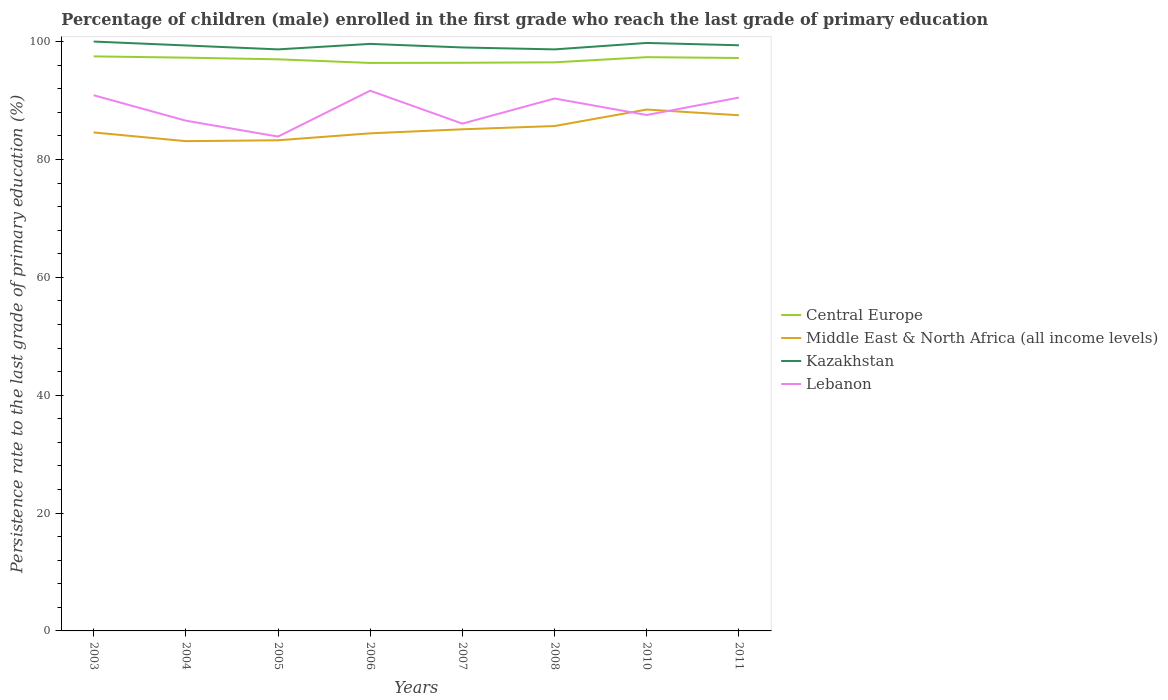Does the line corresponding to Lebanon intersect with the line corresponding to Kazakhstan?
Keep it short and to the point. No. Across all years, what is the maximum persistence rate of children in Middle East & North Africa (all income levels)?
Your response must be concise. 83.1. In which year was the persistence rate of children in Middle East & North Africa (all income levels) maximum?
Keep it short and to the point. 2004. What is the total persistence rate of children in Kazakhstan in the graph?
Your answer should be very brief. 0.66. What is the difference between the highest and the second highest persistence rate of children in Kazakhstan?
Provide a succinct answer. 1.33. What is the difference between the highest and the lowest persistence rate of children in Central Europe?
Your response must be concise. 5. How many lines are there?
Offer a terse response. 4. What is the difference between two consecutive major ticks on the Y-axis?
Keep it short and to the point. 20. Where does the legend appear in the graph?
Your answer should be very brief. Center right. How many legend labels are there?
Make the answer very short. 4. What is the title of the graph?
Provide a short and direct response. Percentage of children (male) enrolled in the first grade who reach the last grade of primary education. Does "United Arab Emirates" appear as one of the legend labels in the graph?
Offer a terse response. No. What is the label or title of the Y-axis?
Keep it short and to the point. Persistence rate to the last grade of primary education (%). What is the Persistence rate to the last grade of primary education (%) in Central Europe in 2003?
Your response must be concise. 97.48. What is the Persistence rate to the last grade of primary education (%) in Middle East & North Africa (all income levels) in 2003?
Your response must be concise. 84.58. What is the Persistence rate to the last grade of primary education (%) of Lebanon in 2003?
Offer a terse response. 90.89. What is the Persistence rate to the last grade of primary education (%) in Central Europe in 2004?
Give a very brief answer. 97.27. What is the Persistence rate to the last grade of primary education (%) of Middle East & North Africa (all income levels) in 2004?
Offer a terse response. 83.1. What is the Persistence rate to the last grade of primary education (%) in Kazakhstan in 2004?
Provide a short and direct response. 99.34. What is the Persistence rate to the last grade of primary education (%) of Lebanon in 2004?
Provide a short and direct response. 86.58. What is the Persistence rate to the last grade of primary education (%) in Central Europe in 2005?
Provide a succinct answer. 96.99. What is the Persistence rate to the last grade of primary education (%) in Middle East & North Africa (all income levels) in 2005?
Provide a succinct answer. 83.25. What is the Persistence rate to the last grade of primary education (%) of Kazakhstan in 2005?
Offer a terse response. 98.67. What is the Persistence rate to the last grade of primary education (%) of Lebanon in 2005?
Give a very brief answer. 83.88. What is the Persistence rate to the last grade of primary education (%) of Central Europe in 2006?
Ensure brevity in your answer.  96.37. What is the Persistence rate to the last grade of primary education (%) in Middle East & North Africa (all income levels) in 2006?
Make the answer very short. 84.43. What is the Persistence rate to the last grade of primary education (%) of Kazakhstan in 2006?
Your answer should be compact. 99.6. What is the Persistence rate to the last grade of primary education (%) of Lebanon in 2006?
Your response must be concise. 91.66. What is the Persistence rate to the last grade of primary education (%) of Central Europe in 2007?
Give a very brief answer. 96.4. What is the Persistence rate to the last grade of primary education (%) in Middle East & North Africa (all income levels) in 2007?
Your answer should be very brief. 85.11. What is the Persistence rate to the last grade of primary education (%) in Kazakhstan in 2007?
Make the answer very short. 99. What is the Persistence rate to the last grade of primary education (%) in Lebanon in 2007?
Offer a very short reply. 86.07. What is the Persistence rate to the last grade of primary education (%) of Central Europe in 2008?
Your response must be concise. 96.48. What is the Persistence rate to the last grade of primary education (%) in Middle East & North Africa (all income levels) in 2008?
Your answer should be very brief. 85.67. What is the Persistence rate to the last grade of primary education (%) of Kazakhstan in 2008?
Keep it short and to the point. 98.67. What is the Persistence rate to the last grade of primary education (%) in Lebanon in 2008?
Provide a short and direct response. 90.33. What is the Persistence rate to the last grade of primary education (%) in Central Europe in 2010?
Make the answer very short. 97.35. What is the Persistence rate to the last grade of primary education (%) of Middle East & North Africa (all income levels) in 2010?
Provide a succinct answer. 88.46. What is the Persistence rate to the last grade of primary education (%) in Kazakhstan in 2010?
Your answer should be very brief. 99.77. What is the Persistence rate to the last grade of primary education (%) of Lebanon in 2010?
Provide a short and direct response. 87.54. What is the Persistence rate to the last grade of primary education (%) of Central Europe in 2011?
Give a very brief answer. 97.21. What is the Persistence rate to the last grade of primary education (%) in Middle East & North Africa (all income levels) in 2011?
Your answer should be very brief. 87.49. What is the Persistence rate to the last grade of primary education (%) in Kazakhstan in 2011?
Your answer should be very brief. 99.37. What is the Persistence rate to the last grade of primary education (%) of Lebanon in 2011?
Provide a short and direct response. 90.49. Across all years, what is the maximum Persistence rate to the last grade of primary education (%) of Central Europe?
Offer a very short reply. 97.48. Across all years, what is the maximum Persistence rate to the last grade of primary education (%) in Middle East & North Africa (all income levels)?
Offer a very short reply. 88.46. Across all years, what is the maximum Persistence rate to the last grade of primary education (%) of Lebanon?
Your response must be concise. 91.66. Across all years, what is the minimum Persistence rate to the last grade of primary education (%) of Central Europe?
Give a very brief answer. 96.37. Across all years, what is the minimum Persistence rate to the last grade of primary education (%) in Middle East & North Africa (all income levels)?
Your answer should be compact. 83.1. Across all years, what is the minimum Persistence rate to the last grade of primary education (%) in Kazakhstan?
Ensure brevity in your answer.  98.67. Across all years, what is the minimum Persistence rate to the last grade of primary education (%) of Lebanon?
Offer a terse response. 83.88. What is the total Persistence rate to the last grade of primary education (%) of Central Europe in the graph?
Ensure brevity in your answer.  775.55. What is the total Persistence rate to the last grade of primary education (%) of Middle East & North Africa (all income levels) in the graph?
Provide a short and direct response. 682.09. What is the total Persistence rate to the last grade of primary education (%) of Kazakhstan in the graph?
Provide a short and direct response. 794.42. What is the total Persistence rate to the last grade of primary education (%) in Lebanon in the graph?
Provide a short and direct response. 707.45. What is the difference between the Persistence rate to the last grade of primary education (%) of Central Europe in 2003 and that in 2004?
Give a very brief answer. 0.22. What is the difference between the Persistence rate to the last grade of primary education (%) of Middle East & North Africa (all income levels) in 2003 and that in 2004?
Your answer should be very brief. 1.48. What is the difference between the Persistence rate to the last grade of primary education (%) in Kazakhstan in 2003 and that in 2004?
Offer a very short reply. 0.66. What is the difference between the Persistence rate to the last grade of primary education (%) in Lebanon in 2003 and that in 2004?
Give a very brief answer. 4.31. What is the difference between the Persistence rate to the last grade of primary education (%) of Central Europe in 2003 and that in 2005?
Keep it short and to the point. 0.5. What is the difference between the Persistence rate to the last grade of primary education (%) in Middle East & North Africa (all income levels) in 2003 and that in 2005?
Make the answer very short. 1.33. What is the difference between the Persistence rate to the last grade of primary education (%) in Kazakhstan in 2003 and that in 2005?
Provide a short and direct response. 1.33. What is the difference between the Persistence rate to the last grade of primary education (%) in Lebanon in 2003 and that in 2005?
Keep it short and to the point. 7.01. What is the difference between the Persistence rate to the last grade of primary education (%) in Central Europe in 2003 and that in 2006?
Make the answer very short. 1.11. What is the difference between the Persistence rate to the last grade of primary education (%) in Middle East & North Africa (all income levels) in 2003 and that in 2006?
Keep it short and to the point. 0.15. What is the difference between the Persistence rate to the last grade of primary education (%) in Kazakhstan in 2003 and that in 2006?
Your response must be concise. 0.4. What is the difference between the Persistence rate to the last grade of primary education (%) in Lebanon in 2003 and that in 2006?
Ensure brevity in your answer.  -0.77. What is the difference between the Persistence rate to the last grade of primary education (%) of Central Europe in 2003 and that in 2007?
Your answer should be compact. 1.08. What is the difference between the Persistence rate to the last grade of primary education (%) in Middle East & North Africa (all income levels) in 2003 and that in 2007?
Keep it short and to the point. -0.53. What is the difference between the Persistence rate to the last grade of primary education (%) of Lebanon in 2003 and that in 2007?
Make the answer very short. 4.82. What is the difference between the Persistence rate to the last grade of primary education (%) of Central Europe in 2003 and that in 2008?
Your answer should be very brief. 1.01. What is the difference between the Persistence rate to the last grade of primary education (%) of Middle East & North Africa (all income levels) in 2003 and that in 2008?
Make the answer very short. -1.09. What is the difference between the Persistence rate to the last grade of primary education (%) in Kazakhstan in 2003 and that in 2008?
Offer a very short reply. 1.33. What is the difference between the Persistence rate to the last grade of primary education (%) of Lebanon in 2003 and that in 2008?
Provide a short and direct response. 0.56. What is the difference between the Persistence rate to the last grade of primary education (%) in Central Europe in 2003 and that in 2010?
Offer a very short reply. 0.13. What is the difference between the Persistence rate to the last grade of primary education (%) in Middle East & North Africa (all income levels) in 2003 and that in 2010?
Your answer should be compact. -3.88. What is the difference between the Persistence rate to the last grade of primary education (%) of Kazakhstan in 2003 and that in 2010?
Your response must be concise. 0.23. What is the difference between the Persistence rate to the last grade of primary education (%) in Lebanon in 2003 and that in 2010?
Give a very brief answer. 3.35. What is the difference between the Persistence rate to the last grade of primary education (%) of Central Europe in 2003 and that in 2011?
Your answer should be compact. 0.27. What is the difference between the Persistence rate to the last grade of primary education (%) of Middle East & North Africa (all income levels) in 2003 and that in 2011?
Provide a succinct answer. -2.91. What is the difference between the Persistence rate to the last grade of primary education (%) in Kazakhstan in 2003 and that in 2011?
Your answer should be compact. 0.63. What is the difference between the Persistence rate to the last grade of primary education (%) in Lebanon in 2003 and that in 2011?
Your response must be concise. 0.4. What is the difference between the Persistence rate to the last grade of primary education (%) of Central Europe in 2004 and that in 2005?
Provide a succinct answer. 0.28. What is the difference between the Persistence rate to the last grade of primary education (%) in Middle East & North Africa (all income levels) in 2004 and that in 2005?
Your answer should be compact. -0.15. What is the difference between the Persistence rate to the last grade of primary education (%) of Kazakhstan in 2004 and that in 2005?
Keep it short and to the point. 0.66. What is the difference between the Persistence rate to the last grade of primary education (%) of Lebanon in 2004 and that in 2005?
Offer a terse response. 2.7. What is the difference between the Persistence rate to the last grade of primary education (%) in Central Europe in 2004 and that in 2006?
Your answer should be very brief. 0.9. What is the difference between the Persistence rate to the last grade of primary education (%) of Middle East & North Africa (all income levels) in 2004 and that in 2006?
Your answer should be very brief. -1.33. What is the difference between the Persistence rate to the last grade of primary education (%) of Kazakhstan in 2004 and that in 2006?
Your answer should be compact. -0.27. What is the difference between the Persistence rate to the last grade of primary education (%) of Lebanon in 2004 and that in 2006?
Give a very brief answer. -5.09. What is the difference between the Persistence rate to the last grade of primary education (%) in Central Europe in 2004 and that in 2007?
Your answer should be compact. 0.87. What is the difference between the Persistence rate to the last grade of primary education (%) in Middle East & North Africa (all income levels) in 2004 and that in 2007?
Keep it short and to the point. -2.01. What is the difference between the Persistence rate to the last grade of primary education (%) of Kazakhstan in 2004 and that in 2007?
Your answer should be compact. 0.34. What is the difference between the Persistence rate to the last grade of primary education (%) in Lebanon in 2004 and that in 2007?
Your answer should be compact. 0.5. What is the difference between the Persistence rate to the last grade of primary education (%) in Central Europe in 2004 and that in 2008?
Make the answer very short. 0.79. What is the difference between the Persistence rate to the last grade of primary education (%) in Middle East & North Africa (all income levels) in 2004 and that in 2008?
Ensure brevity in your answer.  -2.57. What is the difference between the Persistence rate to the last grade of primary education (%) in Kazakhstan in 2004 and that in 2008?
Make the answer very short. 0.67. What is the difference between the Persistence rate to the last grade of primary education (%) in Lebanon in 2004 and that in 2008?
Ensure brevity in your answer.  -3.76. What is the difference between the Persistence rate to the last grade of primary education (%) in Central Europe in 2004 and that in 2010?
Offer a terse response. -0.09. What is the difference between the Persistence rate to the last grade of primary education (%) of Middle East & North Africa (all income levels) in 2004 and that in 2010?
Ensure brevity in your answer.  -5.36. What is the difference between the Persistence rate to the last grade of primary education (%) of Kazakhstan in 2004 and that in 2010?
Your answer should be compact. -0.43. What is the difference between the Persistence rate to the last grade of primary education (%) of Lebanon in 2004 and that in 2010?
Offer a terse response. -0.96. What is the difference between the Persistence rate to the last grade of primary education (%) in Central Europe in 2004 and that in 2011?
Your answer should be compact. 0.06. What is the difference between the Persistence rate to the last grade of primary education (%) in Middle East & North Africa (all income levels) in 2004 and that in 2011?
Provide a succinct answer. -4.39. What is the difference between the Persistence rate to the last grade of primary education (%) of Kazakhstan in 2004 and that in 2011?
Offer a very short reply. -0.03. What is the difference between the Persistence rate to the last grade of primary education (%) in Lebanon in 2004 and that in 2011?
Offer a terse response. -3.92. What is the difference between the Persistence rate to the last grade of primary education (%) in Central Europe in 2005 and that in 2006?
Your response must be concise. 0.61. What is the difference between the Persistence rate to the last grade of primary education (%) in Middle East & North Africa (all income levels) in 2005 and that in 2006?
Provide a short and direct response. -1.18. What is the difference between the Persistence rate to the last grade of primary education (%) of Kazakhstan in 2005 and that in 2006?
Give a very brief answer. -0.93. What is the difference between the Persistence rate to the last grade of primary education (%) in Lebanon in 2005 and that in 2006?
Give a very brief answer. -7.78. What is the difference between the Persistence rate to the last grade of primary education (%) of Central Europe in 2005 and that in 2007?
Your answer should be very brief. 0.59. What is the difference between the Persistence rate to the last grade of primary education (%) in Middle East & North Africa (all income levels) in 2005 and that in 2007?
Provide a succinct answer. -1.86. What is the difference between the Persistence rate to the last grade of primary education (%) in Kazakhstan in 2005 and that in 2007?
Offer a very short reply. -0.33. What is the difference between the Persistence rate to the last grade of primary education (%) in Lebanon in 2005 and that in 2007?
Your answer should be very brief. -2.19. What is the difference between the Persistence rate to the last grade of primary education (%) of Central Europe in 2005 and that in 2008?
Ensure brevity in your answer.  0.51. What is the difference between the Persistence rate to the last grade of primary education (%) in Middle East & North Africa (all income levels) in 2005 and that in 2008?
Your response must be concise. -2.41. What is the difference between the Persistence rate to the last grade of primary education (%) in Kazakhstan in 2005 and that in 2008?
Provide a short and direct response. 0. What is the difference between the Persistence rate to the last grade of primary education (%) in Lebanon in 2005 and that in 2008?
Make the answer very short. -6.46. What is the difference between the Persistence rate to the last grade of primary education (%) of Central Europe in 2005 and that in 2010?
Offer a terse response. -0.37. What is the difference between the Persistence rate to the last grade of primary education (%) of Middle East & North Africa (all income levels) in 2005 and that in 2010?
Offer a very short reply. -5.21. What is the difference between the Persistence rate to the last grade of primary education (%) in Kazakhstan in 2005 and that in 2010?
Keep it short and to the point. -1.09. What is the difference between the Persistence rate to the last grade of primary education (%) of Lebanon in 2005 and that in 2010?
Offer a terse response. -3.66. What is the difference between the Persistence rate to the last grade of primary education (%) in Central Europe in 2005 and that in 2011?
Provide a short and direct response. -0.22. What is the difference between the Persistence rate to the last grade of primary education (%) of Middle East & North Africa (all income levels) in 2005 and that in 2011?
Make the answer very short. -4.24. What is the difference between the Persistence rate to the last grade of primary education (%) of Kazakhstan in 2005 and that in 2011?
Provide a succinct answer. -0.7. What is the difference between the Persistence rate to the last grade of primary education (%) in Lebanon in 2005 and that in 2011?
Give a very brief answer. -6.61. What is the difference between the Persistence rate to the last grade of primary education (%) in Central Europe in 2006 and that in 2007?
Ensure brevity in your answer.  -0.03. What is the difference between the Persistence rate to the last grade of primary education (%) in Middle East & North Africa (all income levels) in 2006 and that in 2007?
Keep it short and to the point. -0.68. What is the difference between the Persistence rate to the last grade of primary education (%) of Kazakhstan in 2006 and that in 2007?
Offer a terse response. 0.6. What is the difference between the Persistence rate to the last grade of primary education (%) of Lebanon in 2006 and that in 2007?
Offer a very short reply. 5.59. What is the difference between the Persistence rate to the last grade of primary education (%) of Central Europe in 2006 and that in 2008?
Ensure brevity in your answer.  -0.1. What is the difference between the Persistence rate to the last grade of primary education (%) in Middle East & North Africa (all income levels) in 2006 and that in 2008?
Make the answer very short. -1.24. What is the difference between the Persistence rate to the last grade of primary education (%) of Kazakhstan in 2006 and that in 2008?
Your answer should be compact. 0.93. What is the difference between the Persistence rate to the last grade of primary education (%) of Lebanon in 2006 and that in 2008?
Offer a terse response. 1.33. What is the difference between the Persistence rate to the last grade of primary education (%) of Central Europe in 2006 and that in 2010?
Give a very brief answer. -0.98. What is the difference between the Persistence rate to the last grade of primary education (%) in Middle East & North Africa (all income levels) in 2006 and that in 2010?
Give a very brief answer. -4.04. What is the difference between the Persistence rate to the last grade of primary education (%) in Kazakhstan in 2006 and that in 2010?
Your answer should be compact. -0.16. What is the difference between the Persistence rate to the last grade of primary education (%) of Lebanon in 2006 and that in 2010?
Offer a very short reply. 4.13. What is the difference between the Persistence rate to the last grade of primary education (%) of Central Europe in 2006 and that in 2011?
Provide a short and direct response. -0.84. What is the difference between the Persistence rate to the last grade of primary education (%) in Middle East & North Africa (all income levels) in 2006 and that in 2011?
Keep it short and to the point. -3.06. What is the difference between the Persistence rate to the last grade of primary education (%) of Kazakhstan in 2006 and that in 2011?
Your response must be concise. 0.23. What is the difference between the Persistence rate to the last grade of primary education (%) of Lebanon in 2006 and that in 2011?
Give a very brief answer. 1.17. What is the difference between the Persistence rate to the last grade of primary education (%) of Central Europe in 2007 and that in 2008?
Your answer should be very brief. -0.08. What is the difference between the Persistence rate to the last grade of primary education (%) in Middle East & North Africa (all income levels) in 2007 and that in 2008?
Provide a short and direct response. -0.55. What is the difference between the Persistence rate to the last grade of primary education (%) in Kazakhstan in 2007 and that in 2008?
Your answer should be very brief. 0.33. What is the difference between the Persistence rate to the last grade of primary education (%) in Lebanon in 2007 and that in 2008?
Offer a very short reply. -4.26. What is the difference between the Persistence rate to the last grade of primary education (%) of Central Europe in 2007 and that in 2010?
Your response must be concise. -0.95. What is the difference between the Persistence rate to the last grade of primary education (%) of Middle East & North Africa (all income levels) in 2007 and that in 2010?
Offer a very short reply. -3.35. What is the difference between the Persistence rate to the last grade of primary education (%) in Kazakhstan in 2007 and that in 2010?
Make the answer very short. -0.77. What is the difference between the Persistence rate to the last grade of primary education (%) in Lebanon in 2007 and that in 2010?
Offer a terse response. -1.46. What is the difference between the Persistence rate to the last grade of primary education (%) in Central Europe in 2007 and that in 2011?
Give a very brief answer. -0.81. What is the difference between the Persistence rate to the last grade of primary education (%) of Middle East & North Africa (all income levels) in 2007 and that in 2011?
Give a very brief answer. -2.38. What is the difference between the Persistence rate to the last grade of primary education (%) in Kazakhstan in 2007 and that in 2011?
Provide a short and direct response. -0.37. What is the difference between the Persistence rate to the last grade of primary education (%) in Lebanon in 2007 and that in 2011?
Keep it short and to the point. -4.42. What is the difference between the Persistence rate to the last grade of primary education (%) in Central Europe in 2008 and that in 2010?
Your answer should be very brief. -0.88. What is the difference between the Persistence rate to the last grade of primary education (%) in Middle East & North Africa (all income levels) in 2008 and that in 2010?
Your answer should be compact. -2.8. What is the difference between the Persistence rate to the last grade of primary education (%) in Kazakhstan in 2008 and that in 2010?
Your response must be concise. -1.1. What is the difference between the Persistence rate to the last grade of primary education (%) in Lebanon in 2008 and that in 2010?
Give a very brief answer. 2.8. What is the difference between the Persistence rate to the last grade of primary education (%) in Central Europe in 2008 and that in 2011?
Offer a very short reply. -0.74. What is the difference between the Persistence rate to the last grade of primary education (%) in Middle East & North Africa (all income levels) in 2008 and that in 2011?
Offer a terse response. -1.83. What is the difference between the Persistence rate to the last grade of primary education (%) of Kazakhstan in 2008 and that in 2011?
Your answer should be compact. -0.7. What is the difference between the Persistence rate to the last grade of primary education (%) in Lebanon in 2008 and that in 2011?
Keep it short and to the point. -0.16. What is the difference between the Persistence rate to the last grade of primary education (%) in Central Europe in 2010 and that in 2011?
Give a very brief answer. 0.14. What is the difference between the Persistence rate to the last grade of primary education (%) of Middle East & North Africa (all income levels) in 2010 and that in 2011?
Your response must be concise. 0.97. What is the difference between the Persistence rate to the last grade of primary education (%) of Kazakhstan in 2010 and that in 2011?
Give a very brief answer. 0.4. What is the difference between the Persistence rate to the last grade of primary education (%) of Lebanon in 2010 and that in 2011?
Provide a short and direct response. -2.96. What is the difference between the Persistence rate to the last grade of primary education (%) in Central Europe in 2003 and the Persistence rate to the last grade of primary education (%) in Middle East & North Africa (all income levels) in 2004?
Keep it short and to the point. 14.38. What is the difference between the Persistence rate to the last grade of primary education (%) in Central Europe in 2003 and the Persistence rate to the last grade of primary education (%) in Kazakhstan in 2004?
Provide a short and direct response. -1.85. What is the difference between the Persistence rate to the last grade of primary education (%) in Central Europe in 2003 and the Persistence rate to the last grade of primary education (%) in Lebanon in 2004?
Your answer should be compact. 10.91. What is the difference between the Persistence rate to the last grade of primary education (%) in Middle East & North Africa (all income levels) in 2003 and the Persistence rate to the last grade of primary education (%) in Kazakhstan in 2004?
Keep it short and to the point. -14.76. What is the difference between the Persistence rate to the last grade of primary education (%) of Middle East & North Africa (all income levels) in 2003 and the Persistence rate to the last grade of primary education (%) of Lebanon in 2004?
Make the answer very short. -2. What is the difference between the Persistence rate to the last grade of primary education (%) in Kazakhstan in 2003 and the Persistence rate to the last grade of primary education (%) in Lebanon in 2004?
Your response must be concise. 13.42. What is the difference between the Persistence rate to the last grade of primary education (%) of Central Europe in 2003 and the Persistence rate to the last grade of primary education (%) of Middle East & North Africa (all income levels) in 2005?
Offer a terse response. 14.23. What is the difference between the Persistence rate to the last grade of primary education (%) of Central Europe in 2003 and the Persistence rate to the last grade of primary education (%) of Kazakhstan in 2005?
Your answer should be compact. -1.19. What is the difference between the Persistence rate to the last grade of primary education (%) of Central Europe in 2003 and the Persistence rate to the last grade of primary education (%) of Lebanon in 2005?
Keep it short and to the point. 13.61. What is the difference between the Persistence rate to the last grade of primary education (%) of Middle East & North Africa (all income levels) in 2003 and the Persistence rate to the last grade of primary education (%) of Kazakhstan in 2005?
Your answer should be very brief. -14.09. What is the difference between the Persistence rate to the last grade of primary education (%) in Middle East & North Africa (all income levels) in 2003 and the Persistence rate to the last grade of primary education (%) in Lebanon in 2005?
Give a very brief answer. 0.7. What is the difference between the Persistence rate to the last grade of primary education (%) in Kazakhstan in 2003 and the Persistence rate to the last grade of primary education (%) in Lebanon in 2005?
Make the answer very short. 16.12. What is the difference between the Persistence rate to the last grade of primary education (%) of Central Europe in 2003 and the Persistence rate to the last grade of primary education (%) of Middle East & North Africa (all income levels) in 2006?
Make the answer very short. 13.06. What is the difference between the Persistence rate to the last grade of primary education (%) of Central Europe in 2003 and the Persistence rate to the last grade of primary education (%) of Kazakhstan in 2006?
Your answer should be compact. -2.12. What is the difference between the Persistence rate to the last grade of primary education (%) of Central Europe in 2003 and the Persistence rate to the last grade of primary education (%) of Lebanon in 2006?
Ensure brevity in your answer.  5.82. What is the difference between the Persistence rate to the last grade of primary education (%) in Middle East & North Africa (all income levels) in 2003 and the Persistence rate to the last grade of primary education (%) in Kazakhstan in 2006?
Offer a terse response. -15.02. What is the difference between the Persistence rate to the last grade of primary education (%) of Middle East & North Africa (all income levels) in 2003 and the Persistence rate to the last grade of primary education (%) of Lebanon in 2006?
Your answer should be compact. -7.08. What is the difference between the Persistence rate to the last grade of primary education (%) in Kazakhstan in 2003 and the Persistence rate to the last grade of primary education (%) in Lebanon in 2006?
Make the answer very short. 8.34. What is the difference between the Persistence rate to the last grade of primary education (%) of Central Europe in 2003 and the Persistence rate to the last grade of primary education (%) of Middle East & North Africa (all income levels) in 2007?
Keep it short and to the point. 12.37. What is the difference between the Persistence rate to the last grade of primary education (%) of Central Europe in 2003 and the Persistence rate to the last grade of primary education (%) of Kazakhstan in 2007?
Give a very brief answer. -1.51. What is the difference between the Persistence rate to the last grade of primary education (%) in Central Europe in 2003 and the Persistence rate to the last grade of primary education (%) in Lebanon in 2007?
Make the answer very short. 11.41. What is the difference between the Persistence rate to the last grade of primary education (%) in Middle East & North Africa (all income levels) in 2003 and the Persistence rate to the last grade of primary education (%) in Kazakhstan in 2007?
Your answer should be compact. -14.42. What is the difference between the Persistence rate to the last grade of primary education (%) of Middle East & North Africa (all income levels) in 2003 and the Persistence rate to the last grade of primary education (%) of Lebanon in 2007?
Make the answer very short. -1.49. What is the difference between the Persistence rate to the last grade of primary education (%) in Kazakhstan in 2003 and the Persistence rate to the last grade of primary education (%) in Lebanon in 2007?
Your answer should be compact. 13.93. What is the difference between the Persistence rate to the last grade of primary education (%) of Central Europe in 2003 and the Persistence rate to the last grade of primary education (%) of Middle East & North Africa (all income levels) in 2008?
Your answer should be compact. 11.82. What is the difference between the Persistence rate to the last grade of primary education (%) in Central Europe in 2003 and the Persistence rate to the last grade of primary education (%) in Kazakhstan in 2008?
Offer a terse response. -1.19. What is the difference between the Persistence rate to the last grade of primary education (%) in Central Europe in 2003 and the Persistence rate to the last grade of primary education (%) in Lebanon in 2008?
Your answer should be compact. 7.15. What is the difference between the Persistence rate to the last grade of primary education (%) in Middle East & North Africa (all income levels) in 2003 and the Persistence rate to the last grade of primary education (%) in Kazakhstan in 2008?
Keep it short and to the point. -14.09. What is the difference between the Persistence rate to the last grade of primary education (%) of Middle East & North Africa (all income levels) in 2003 and the Persistence rate to the last grade of primary education (%) of Lebanon in 2008?
Keep it short and to the point. -5.75. What is the difference between the Persistence rate to the last grade of primary education (%) in Kazakhstan in 2003 and the Persistence rate to the last grade of primary education (%) in Lebanon in 2008?
Offer a terse response. 9.67. What is the difference between the Persistence rate to the last grade of primary education (%) in Central Europe in 2003 and the Persistence rate to the last grade of primary education (%) in Middle East & North Africa (all income levels) in 2010?
Ensure brevity in your answer.  9.02. What is the difference between the Persistence rate to the last grade of primary education (%) of Central Europe in 2003 and the Persistence rate to the last grade of primary education (%) of Kazakhstan in 2010?
Provide a succinct answer. -2.28. What is the difference between the Persistence rate to the last grade of primary education (%) of Central Europe in 2003 and the Persistence rate to the last grade of primary education (%) of Lebanon in 2010?
Your response must be concise. 9.95. What is the difference between the Persistence rate to the last grade of primary education (%) of Middle East & North Africa (all income levels) in 2003 and the Persistence rate to the last grade of primary education (%) of Kazakhstan in 2010?
Keep it short and to the point. -15.19. What is the difference between the Persistence rate to the last grade of primary education (%) in Middle East & North Africa (all income levels) in 2003 and the Persistence rate to the last grade of primary education (%) in Lebanon in 2010?
Offer a very short reply. -2.96. What is the difference between the Persistence rate to the last grade of primary education (%) of Kazakhstan in 2003 and the Persistence rate to the last grade of primary education (%) of Lebanon in 2010?
Provide a succinct answer. 12.46. What is the difference between the Persistence rate to the last grade of primary education (%) of Central Europe in 2003 and the Persistence rate to the last grade of primary education (%) of Middle East & North Africa (all income levels) in 2011?
Offer a very short reply. 9.99. What is the difference between the Persistence rate to the last grade of primary education (%) of Central Europe in 2003 and the Persistence rate to the last grade of primary education (%) of Kazakhstan in 2011?
Make the answer very short. -1.89. What is the difference between the Persistence rate to the last grade of primary education (%) of Central Europe in 2003 and the Persistence rate to the last grade of primary education (%) of Lebanon in 2011?
Make the answer very short. 6.99. What is the difference between the Persistence rate to the last grade of primary education (%) of Middle East & North Africa (all income levels) in 2003 and the Persistence rate to the last grade of primary education (%) of Kazakhstan in 2011?
Ensure brevity in your answer.  -14.79. What is the difference between the Persistence rate to the last grade of primary education (%) of Middle East & North Africa (all income levels) in 2003 and the Persistence rate to the last grade of primary education (%) of Lebanon in 2011?
Make the answer very short. -5.91. What is the difference between the Persistence rate to the last grade of primary education (%) in Kazakhstan in 2003 and the Persistence rate to the last grade of primary education (%) in Lebanon in 2011?
Keep it short and to the point. 9.51. What is the difference between the Persistence rate to the last grade of primary education (%) in Central Europe in 2004 and the Persistence rate to the last grade of primary education (%) in Middle East & North Africa (all income levels) in 2005?
Your answer should be compact. 14.02. What is the difference between the Persistence rate to the last grade of primary education (%) of Central Europe in 2004 and the Persistence rate to the last grade of primary education (%) of Kazakhstan in 2005?
Ensure brevity in your answer.  -1.41. What is the difference between the Persistence rate to the last grade of primary education (%) of Central Europe in 2004 and the Persistence rate to the last grade of primary education (%) of Lebanon in 2005?
Ensure brevity in your answer.  13.39. What is the difference between the Persistence rate to the last grade of primary education (%) of Middle East & North Africa (all income levels) in 2004 and the Persistence rate to the last grade of primary education (%) of Kazakhstan in 2005?
Offer a terse response. -15.57. What is the difference between the Persistence rate to the last grade of primary education (%) in Middle East & North Africa (all income levels) in 2004 and the Persistence rate to the last grade of primary education (%) in Lebanon in 2005?
Make the answer very short. -0.78. What is the difference between the Persistence rate to the last grade of primary education (%) in Kazakhstan in 2004 and the Persistence rate to the last grade of primary education (%) in Lebanon in 2005?
Ensure brevity in your answer.  15.46. What is the difference between the Persistence rate to the last grade of primary education (%) of Central Europe in 2004 and the Persistence rate to the last grade of primary education (%) of Middle East & North Africa (all income levels) in 2006?
Your answer should be very brief. 12.84. What is the difference between the Persistence rate to the last grade of primary education (%) in Central Europe in 2004 and the Persistence rate to the last grade of primary education (%) in Kazakhstan in 2006?
Your response must be concise. -2.34. What is the difference between the Persistence rate to the last grade of primary education (%) of Central Europe in 2004 and the Persistence rate to the last grade of primary education (%) of Lebanon in 2006?
Offer a very short reply. 5.61. What is the difference between the Persistence rate to the last grade of primary education (%) of Middle East & North Africa (all income levels) in 2004 and the Persistence rate to the last grade of primary education (%) of Kazakhstan in 2006?
Give a very brief answer. -16.5. What is the difference between the Persistence rate to the last grade of primary education (%) of Middle East & North Africa (all income levels) in 2004 and the Persistence rate to the last grade of primary education (%) of Lebanon in 2006?
Keep it short and to the point. -8.56. What is the difference between the Persistence rate to the last grade of primary education (%) in Kazakhstan in 2004 and the Persistence rate to the last grade of primary education (%) in Lebanon in 2006?
Your answer should be compact. 7.68. What is the difference between the Persistence rate to the last grade of primary education (%) in Central Europe in 2004 and the Persistence rate to the last grade of primary education (%) in Middle East & North Africa (all income levels) in 2007?
Your answer should be compact. 12.16. What is the difference between the Persistence rate to the last grade of primary education (%) of Central Europe in 2004 and the Persistence rate to the last grade of primary education (%) of Kazakhstan in 2007?
Offer a very short reply. -1.73. What is the difference between the Persistence rate to the last grade of primary education (%) in Central Europe in 2004 and the Persistence rate to the last grade of primary education (%) in Lebanon in 2007?
Offer a terse response. 11.19. What is the difference between the Persistence rate to the last grade of primary education (%) in Middle East & North Africa (all income levels) in 2004 and the Persistence rate to the last grade of primary education (%) in Kazakhstan in 2007?
Your response must be concise. -15.9. What is the difference between the Persistence rate to the last grade of primary education (%) of Middle East & North Africa (all income levels) in 2004 and the Persistence rate to the last grade of primary education (%) of Lebanon in 2007?
Give a very brief answer. -2.97. What is the difference between the Persistence rate to the last grade of primary education (%) of Kazakhstan in 2004 and the Persistence rate to the last grade of primary education (%) of Lebanon in 2007?
Keep it short and to the point. 13.26. What is the difference between the Persistence rate to the last grade of primary education (%) of Central Europe in 2004 and the Persistence rate to the last grade of primary education (%) of Middle East & North Africa (all income levels) in 2008?
Your answer should be very brief. 11.6. What is the difference between the Persistence rate to the last grade of primary education (%) of Central Europe in 2004 and the Persistence rate to the last grade of primary education (%) of Kazakhstan in 2008?
Offer a terse response. -1.4. What is the difference between the Persistence rate to the last grade of primary education (%) in Central Europe in 2004 and the Persistence rate to the last grade of primary education (%) in Lebanon in 2008?
Your answer should be compact. 6.93. What is the difference between the Persistence rate to the last grade of primary education (%) of Middle East & North Africa (all income levels) in 2004 and the Persistence rate to the last grade of primary education (%) of Kazakhstan in 2008?
Make the answer very short. -15.57. What is the difference between the Persistence rate to the last grade of primary education (%) in Middle East & North Africa (all income levels) in 2004 and the Persistence rate to the last grade of primary education (%) in Lebanon in 2008?
Offer a terse response. -7.23. What is the difference between the Persistence rate to the last grade of primary education (%) in Kazakhstan in 2004 and the Persistence rate to the last grade of primary education (%) in Lebanon in 2008?
Offer a very short reply. 9. What is the difference between the Persistence rate to the last grade of primary education (%) of Central Europe in 2004 and the Persistence rate to the last grade of primary education (%) of Middle East & North Africa (all income levels) in 2010?
Offer a terse response. 8.8. What is the difference between the Persistence rate to the last grade of primary education (%) in Central Europe in 2004 and the Persistence rate to the last grade of primary education (%) in Kazakhstan in 2010?
Keep it short and to the point. -2.5. What is the difference between the Persistence rate to the last grade of primary education (%) in Central Europe in 2004 and the Persistence rate to the last grade of primary education (%) in Lebanon in 2010?
Your answer should be very brief. 9.73. What is the difference between the Persistence rate to the last grade of primary education (%) of Middle East & North Africa (all income levels) in 2004 and the Persistence rate to the last grade of primary education (%) of Kazakhstan in 2010?
Your answer should be very brief. -16.67. What is the difference between the Persistence rate to the last grade of primary education (%) in Middle East & North Africa (all income levels) in 2004 and the Persistence rate to the last grade of primary education (%) in Lebanon in 2010?
Give a very brief answer. -4.44. What is the difference between the Persistence rate to the last grade of primary education (%) in Kazakhstan in 2004 and the Persistence rate to the last grade of primary education (%) in Lebanon in 2010?
Keep it short and to the point. 11.8. What is the difference between the Persistence rate to the last grade of primary education (%) in Central Europe in 2004 and the Persistence rate to the last grade of primary education (%) in Middle East & North Africa (all income levels) in 2011?
Your answer should be very brief. 9.78. What is the difference between the Persistence rate to the last grade of primary education (%) in Central Europe in 2004 and the Persistence rate to the last grade of primary education (%) in Kazakhstan in 2011?
Keep it short and to the point. -2.1. What is the difference between the Persistence rate to the last grade of primary education (%) of Central Europe in 2004 and the Persistence rate to the last grade of primary education (%) of Lebanon in 2011?
Ensure brevity in your answer.  6.78. What is the difference between the Persistence rate to the last grade of primary education (%) of Middle East & North Africa (all income levels) in 2004 and the Persistence rate to the last grade of primary education (%) of Kazakhstan in 2011?
Your answer should be compact. -16.27. What is the difference between the Persistence rate to the last grade of primary education (%) of Middle East & North Africa (all income levels) in 2004 and the Persistence rate to the last grade of primary education (%) of Lebanon in 2011?
Your answer should be compact. -7.39. What is the difference between the Persistence rate to the last grade of primary education (%) of Kazakhstan in 2004 and the Persistence rate to the last grade of primary education (%) of Lebanon in 2011?
Keep it short and to the point. 8.85. What is the difference between the Persistence rate to the last grade of primary education (%) of Central Europe in 2005 and the Persistence rate to the last grade of primary education (%) of Middle East & North Africa (all income levels) in 2006?
Make the answer very short. 12.56. What is the difference between the Persistence rate to the last grade of primary education (%) of Central Europe in 2005 and the Persistence rate to the last grade of primary education (%) of Kazakhstan in 2006?
Offer a very short reply. -2.62. What is the difference between the Persistence rate to the last grade of primary education (%) of Central Europe in 2005 and the Persistence rate to the last grade of primary education (%) of Lebanon in 2006?
Offer a very short reply. 5.33. What is the difference between the Persistence rate to the last grade of primary education (%) in Middle East & North Africa (all income levels) in 2005 and the Persistence rate to the last grade of primary education (%) in Kazakhstan in 2006?
Keep it short and to the point. -16.35. What is the difference between the Persistence rate to the last grade of primary education (%) in Middle East & North Africa (all income levels) in 2005 and the Persistence rate to the last grade of primary education (%) in Lebanon in 2006?
Provide a short and direct response. -8.41. What is the difference between the Persistence rate to the last grade of primary education (%) of Kazakhstan in 2005 and the Persistence rate to the last grade of primary education (%) of Lebanon in 2006?
Ensure brevity in your answer.  7.01. What is the difference between the Persistence rate to the last grade of primary education (%) in Central Europe in 2005 and the Persistence rate to the last grade of primary education (%) in Middle East & North Africa (all income levels) in 2007?
Ensure brevity in your answer.  11.88. What is the difference between the Persistence rate to the last grade of primary education (%) of Central Europe in 2005 and the Persistence rate to the last grade of primary education (%) of Kazakhstan in 2007?
Make the answer very short. -2.01. What is the difference between the Persistence rate to the last grade of primary education (%) of Central Europe in 2005 and the Persistence rate to the last grade of primary education (%) of Lebanon in 2007?
Offer a very short reply. 10.91. What is the difference between the Persistence rate to the last grade of primary education (%) in Middle East & North Africa (all income levels) in 2005 and the Persistence rate to the last grade of primary education (%) in Kazakhstan in 2007?
Provide a short and direct response. -15.75. What is the difference between the Persistence rate to the last grade of primary education (%) in Middle East & North Africa (all income levels) in 2005 and the Persistence rate to the last grade of primary education (%) in Lebanon in 2007?
Ensure brevity in your answer.  -2.82. What is the difference between the Persistence rate to the last grade of primary education (%) in Kazakhstan in 2005 and the Persistence rate to the last grade of primary education (%) in Lebanon in 2007?
Provide a short and direct response. 12.6. What is the difference between the Persistence rate to the last grade of primary education (%) in Central Europe in 2005 and the Persistence rate to the last grade of primary education (%) in Middle East & North Africa (all income levels) in 2008?
Make the answer very short. 11.32. What is the difference between the Persistence rate to the last grade of primary education (%) of Central Europe in 2005 and the Persistence rate to the last grade of primary education (%) of Kazakhstan in 2008?
Provide a succinct answer. -1.68. What is the difference between the Persistence rate to the last grade of primary education (%) of Central Europe in 2005 and the Persistence rate to the last grade of primary education (%) of Lebanon in 2008?
Offer a very short reply. 6.65. What is the difference between the Persistence rate to the last grade of primary education (%) in Middle East & North Africa (all income levels) in 2005 and the Persistence rate to the last grade of primary education (%) in Kazakhstan in 2008?
Ensure brevity in your answer.  -15.42. What is the difference between the Persistence rate to the last grade of primary education (%) of Middle East & North Africa (all income levels) in 2005 and the Persistence rate to the last grade of primary education (%) of Lebanon in 2008?
Provide a succinct answer. -7.08. What is the difference between the Persistence rate to the last grade of primary education (%) in Kazakhstan in 2005 and the Persistence rate to the last grade of primary education (%) in Lebanon in 2008?
Provide a succinct answer. 8.34. What is the difference between the Persistence rate to the last grade of primary education (%) in Central Europe in 2005 and the Persistence rate to the last grade of primary education (%) in Middle East & North Africa (all income levels) in 2010?
Provide a succinct answer. 8.52. What is the difference between the Persistence rate to the last grade of primary education (%) of Central Europe in 2005 and the Persistence rate to the last grade of primary education (%) of Kazakhstan in 2010?
Your answer should be compact. -2.78. What is the difference between the Persistence rate to the last grade of primary education (%) of Central Europe in 2005 and the Persistence rate to the last grade of primary education (%) of Lebanon in 2010?
Offer a very short reply. 9.45. What is the difference between the Persistence rate to the last grade of primary education (%) of Middle East & North Africa (all income levels) in 2005 and the Persistence rate to the last grade of primary education (%) of Kazakhstan in 2010?
Your response must be concise. -16.51. What is the difference between the Persistence rate to the last grade of primary education (%) of Middle East & North Africa (all income levels) in 2005 and the Persistence rate to the last grade of primary education (%) of Lebanon in 2010?
Make the answer very short. -4.28. What is the difference between the Persistence rate to the last grade of primary education (%) of Kazakhstan in 2005 and the Persistence rate to the last grade of primary education (%) of Lebanon in 2010?
Make the answer very short. 11.14. What is the difference between the Persistence rate to the last grade of primary education (%) in Central Europe in 2005 and the Persistence rate to the last grade of primary education (%) in Middle East & North Africa (all income levels) in 2011?
Keep it short and to the point. 9.5. What is the difference between the Persistence rate to the last grade of primary education (%) of Central Europe in 2005 and the Persistence rate to the last grade of primary education (%) of Kazakhstan in 2011?
Provide a short and direct response. -2.38. What is the difference between the Persistence rate to the last grade of primary education (%) in Central Europe in 2005 and the Persistence rate to the last grade of primary education (%) in Lebanon in 2011?
Provide a short and direct response. 6.5. What is the difference between the Persistence rate to the last grade of primary education (%) in Middle East & North Africa (all income levels) in 2005 and the Persistence rate to the last grade of primary education (%) in Kazakhstan in 2011?
Your answer should be very brief. -16.12. What is the difference between the Persistence rate to the last grade of primary education (%) in Middle East & North Africa (all income levels) in 2005 and the Persistence rate to the last grade of primary education (%) in Lebanon in 2011?
Ensure brevity in your answer.  -7.24. What is the difference between the Persistence rate to the last grade of primary education (%) of Kazakhstan in 2005 and the Persistence rate to the last grade of primary education (%) of Lebanon in 2011?
Offer a very short reply. 8.18. What is the difference between the Persistence rate to the last grade of primary education (%) in Central Europe in 2006 and the Persistence rate to the last grade of primary education (%) in Middle East & North Africa (all income levels) in 2007?
Keep it short and to the point. 11.26. What is the difference between the Persistence rate to the last grade of primary education (%) in Central Europe in 2006 and the Persistence rate to the last grade of primary education (%) in Kazakhstan in 2007?
Give a very brief answer. -2.63. What is the difference between the Persistence rate to the last grade of primary education (%) in Central Europe in 2006 and the Persistence rate to the last grade of primary education (%) in Lebanon in 2007?
Offer a terse response. 10.3. What is the difference between the Persistence rate to the last grade of primary education (%) of Middle East & North Africa (all income levels) in 2006 and the Persistence rate to the last grade of primary education (%) of Kazakhstan in 2007?
Your answer should be very brief. -14.57. What is the difference between the Persistence rate to the last grade of primary education (%) of Middle East & North Africa (all income levels) in 2006 and the Persistence rate to the last grade of primary education (%) of Lebanon in 2007?
Keep it short and to the point. -1.65. What is the difference between the Persistence rate to the last grade of primary education (%) in Kazakhstan in 2006 and the Persistence rate to the last grade of primary education (%) in Lebanon in 2007?
Provide a short and direct response. 13.53. What is the difference between the Persistence rate to the last grade of primary education (%) of Central Europe in 2006 and the Persistence rate to the last grade of primary education (%) of Middle East & North Africa (all income levels) in 2008?
Offer a very short reply. 10.71. What is the difference between the Persistence rate to the last grade of primary education (%) in Central Europe in 2006 and the Persistence rate to the last grade of primary education (%) in Kazakhstan in 2008?
Ensure brevity in your answer.  -2.3. What is the difference between the Persistence rate to the last grade of primary education (%) of Central Europe in 2006 and the Persistence rate to the last grade of primary education (%) of Lebanon in 2008?
Make the answer very short. 6.04. What is the difference between the Persistence rate to the last grade of primary education (%) in Middle East & North Africa (all income levels) in 2006 and the Persistence rate to the last grade of primary education (%) in Kazakhstan in 2008?
Provide a short and direct response. -14.24. What is the difference between the Persistence rate to the last grade of primary education (%) in Middle East & North Africa (all income levels) in 2006 and the Persistence rate to the last grade of primary education (%) in Lebanon in 2008?
Give a very brief answer. -5.91. What is the difference between the Persistence rate to the last grade of primary education (%) of Kazakhstan in 2006 and the Persistence rate to the last grade of primary education (%) of Lebanon in 2008?
Offer a very short reply. 9.27. What is the difference between the Persistence rate to the last grade of primary education (%) of Central Europe in 2006 and the Persistence rate to the last grade of primary education (%) of Middle East & North Africa (all income levels) in 2010?
Keep it short and to the point. 7.91. What is the difference between the Persistence rate to the last grade of primary education (%) of Central Europe in 2006 and the Persistence rate to the last grade of primary education (%) of Kazakhstan in 2010?
Make the answer very short. -3.39. What is the difference between the Persistence rate to the last grade of primary education (%) of Central Europe in 2006 and the Persistence rate to the last grade of primary education (%) of Lebanon in 2010?
Your answer should be compact. 8.84. What is the difference between the Persistence rate to the last grade of primary education (%) in Middle East & North Africa (all income levels) in 2006 and the Persistence rate to the last grade of primary education (%) in Kazakhstan in 2010?
Ensure brevity in your answer.  -15.34. What is the difference between the Persistence rate to the last grade of primary education (%) in Middle East & North Africa (all income levels) in 2006 and the Persistence rate to the last grade of primary education (%) in Lebanon in 2010?
Provide a succinct answer. -3.11. What is the difference between the Persistence rate to the last grade of primary education (%) in Kazakhstan in 2006 and the Persistence rate to the last grade of primary education (%) in Lebanon in 2010?
Your answer should be very brief. 12.07. What is the difference between the Persistence rate to the last grade of primary education (%) in Central Europe in 2006 and the Persistence rate to the last grade of primary education (%) in Middle East & North Africa (all income levels) in 2011?
Ensure brevity in your answer.  8.88. What is the difference between the Persistence rate to the last grade of primary education (%) of Central Europe in 2006 and the Persistence rate to the last grade of primary education (%) of Kazakhstan in 2011?
Your answer should be compact. -3. What is the difference between the Persistence rate to the last grade of primary education (%) of Central Europe in 2006 and the Persistence rate to the last grade of primary education (%) of Lebanon in 2011?
Give a very brief answer. 5.88. What is the difference between the Persistence rate to the last grade of primary education (%) in Middle East & North Africa (all income levels) in 2006 and the Persistence rate to the last grade of primary education (%) in Kazakhstan in 2011?
Your response must be concise. -14.94. What is the difference between the Persistence rate to the last grade of primary education (%) of Middle East & North Africa (all income levels) in 2006 and the Persistence rate to the last grade of primary education (%) of Lebanon in 2011?
Offer a terse response. -6.07. What is the difference between the Persistence rate to the last grade of primary education (%) in Kazakhstan in 2006 and the Persistence rate to the last grade of primary education (%) in Lebanon in 2011?
Make the answer very short. 9.11. What is the difference between the Persistence rate to the last grade of primary education (%) in Central Europe in 2007 and the Persistence rate to the last grade of primary education (%) in Middle East & North Africa (all income levels) in 2008?
Ensure brevity in your answer.  10.73. What is the difference between the Persistence rate to the last grade of primary education (%) in Central Europe in 2007 and the Persistence rate to the last grade of primary education (%) in Kazakhstan in 2008?
Your answer should be very brief. -2.27. What is the difference between the Persistence rate to the last grade of primary education (%) of Central Europe in 2007 and the Persistence rate to the last grade of primary education (%) of Lebanon in 2008?
Make the answer very short. 6.07. What is the difference between the Persistence rate to the last grade of primary education (%) in Middle East & North Africa (all income levels) in 2007 and the Persistence rate to the last grade of primary education (%) in Kazakhstan in 2008?
Provide a short and direct response. -13.56. What is the difference between the Persistence rate to the last grade of primary education (%) of Middle East & North Africa (all income levels) in 2007 and the Persistence rate to the last grade of primary education (%) of Lebanon in 2008?
Your answer should be compact. -5.22. What is the difference between the Persistence rate to the last grade of primary education (%) in Kazakhstan in 2007 and the Persistence rate to the last grade of primary education (%) in Lebanon in 2008?
Your answer should be very brief. 8.67. What is the difference between the Persistence rate to the last grade of primary education (%) of Central Europe in 2007 and the Persistence rate to the last grade of primary education (%) of Middle East & North Africa (all income levels) in 2010?
Provide a short and direct response. 7.94. What is the difference between the Persistence rate to the last grade of primary education (%) in Central Europe in 2007 and the Persistence rate to the last grade of primary education (%) in Kazakhstan in 2010?
Provide a short and direct response. -3.37. What is the difference between the Persistence rate to the last grade of primary education (%) in Central Europe in 2007 and the Persistence rate to the last grade of primary education (%) in Lebanon in 2010?
Your answer should be very brief. 8.86. What is the difference between the Persistence rate to the last grade of primary education (%) of Middle East & North Africa (all income levels) in 2007 and the Persistence rate to the last grade of primary education (%) of Kazakhstan in 2010?
Offer a terse response. -14.65. What is the difference between the Persistence rate to the last grade of primary education (%) in Middle East & North Africa (all income levels) in 2007 and the Persistence rate to the last grade of primary education (%) in Lebanon in 2010?
Keep it short and to the point. -2.42. What is the difference between the Persistence rate to the last grade of primary education (%) in Kazakhstan in 2007 and the Persistence rate to the last grade of primary education (%) in Lebanon in 2010?
Provide a short and direct response. 11.46. What is the difference between the Persistence rate to the last grade of primary education (%) in Central Europe in 2007 and the Persistence rate to the last grade of primary education (%) in Middle East & North Africa (all income levels) in 2011?
Provide a succinct answer. 8.91. What is the difference between the Persistence rate to the last grade of primary education (%) of Central Europe in 2007 and the Persistence rate to the last grade of primary education (%) of Kazakhstan in 2011?
Offer a very short reply. -2.97. What is the difference between the Persistence rate to the last grade of primary education (%) in Central Europe in 2007 and the Persistence rate to the last grade of primary education (%) in Lebanon in 2011?
Offer a very short reply. 5.91. What is the difference between the Persistence rate to the last grade of primary education (%) in Middle East & North Africa (all income levels) in 2007 and the Persistence rate to the last grade of primary education (%) in Kazakhstan in 2011?
Keep it short and to the point. -14.26. What is the difference between the Persistence rate to the last grade of primary education (%) of Middle East & North Africa (all income levels) in 2007 and the Persistence rate to the last grade of primary education (%) of Lebanon in 2011?
Provide a short and direct response. -5.38. What is the difference between the Persistence rate to the last grade of primary education (%) of Kazakhstan in 2007 and the Persistence rate to the last grade of primary education (%) of Lebanon in 2011?
Your answer should be compact. 8.51. What is the difference between the Persistence rate to the last grade of primary education (%) of Central Europe in 2008 and the Persistence rate to the last grade of primary education (%) of Middle East & North Africa (all income levels) in 2010?
Make the answer very short. 8.01. What is the difference between the Persistence rate to the last grade of primary education (%) of Central Europe in 2008 and the Persistence rate to the last grade of primary education (%) of Kazakhstan in 2010?
Your response must be concise. -3.29. What is the difference between the Persistence rate to the last grade of primary education (%) of Central Europe in 2008 and the Persistence rate to the last grade of primary education (%) of Lebanon in 2010?
Offer a very short reply. 8.94. What is the difference between the Persistence rate to the last grade of primary education (%) in Middle East & North Africa (all income levels) in 2008 and the Persistence rate to the last grade of primary education (%) in Kazakhstan in 2010?
Provide a succinct answer. -14.1. What is the difference between the Persistence rate to the last grade of primary education (%) of Middle East & North Africa (all income levels) in 2008 and the Persistence rate to the last grade of primary education (%) of Lebanon in 2010?
Offer a terse response. -1.87. What is the difference between the Persistence rate to the last grade of primary education (%) in Kazakhstan in 2008 and the Persistence rate to the last grade of primary education (%) in Lebanon in 2010?
Provide a succinct answer. 11.13. What is the difference between the Persistence rate to the last grade of primary education (%) in Central Europe in 2008 and the Persistence rate to the last grade of primary education (%) in Middle East & North Africa (all income levels) in 2011?
Ensure brevity in your answer.  8.98. What is the difference between the Persistence rate to the last grade of primary education (%) of Central Europe in 2008 and the Persistence rate to the last grade of primary education (%) of Kazakhstan in 2011?
Your response must be concise. -2.9. What is the difference between the Persistence rate to the last grade of primary education (%) of Central Europe in 2008 and the Persistence rate to the last grade of primary education (%) of Lebanon in 2011?
Offer a terse response. 5.98. What is the difference between the Persistence rate to the last grade of primary education (%) of Middle East & North Africa (all income levels) in 2008 and the Persistence rate to the last grade of primary education (%) of Kazakhstan in 2011?
Offer a very short reply. -13.7. What is the difference between the Persistence rate to the last grade of primary education (%) in Middle East & North Africa (all income levels) in 2008 and the Persistence rate to the last grade of primary education (%) in Lebanon in 2011?
Ensure brevity in your answer.  -4.83. What is the difference between the Persistence rate to the last grade of primary education (%) in Kazakhstan in 2008 and the Persistence rate to the last grade of primary education (%) in Lebanon in 2011?
Your answer should be very brief. 8.18. What is the difference between the Persistence rate to the last grade of primary education (%) of Central Europe in 2010 and the Persistence rate to the last grade of primary education (%) of Middle East & North Africa (all income levels) in 2011?
Your response must be concise. 9.86. What is the difference between the Persistence rate to the last grade of primary education (%) in Central Europe in 2010 and the Persistence rate to the last grade of primary education (%) in Kazakhstan in 2011?
Your answer should be very brief. -2.02. What is the difference between the Persistence rate to the last grade of primary education (%) in Central Europe in 2010 and the Persistence rate to the last grade of primary education (%) in Lebanon in 2011?
Your answer should be very brief. 6.86. What is the difference between the Persistence rate to the last grade of primary education (%) in Middle East & North Africa (all income levels) in 2010 and the Persistence rate to the last grade of primary education (%) in Kazakhstan in 2011?
Keep it short and to the point. -10.91. What is the difference between the Persistence rate to the last grade of primary education (%) in Middle East & North Africa (all income levels) in 2010 and the Persistence rate to the last grade of primary education (%) in Lebanon in 2011?
Your answer should be compact. -2.03. What is the difference between the Persistence rate to the last grade of primary education (%) in Kazakhstan in 2010 and the Persistence rate to the last grade of primary education (%) in Lebanon in 2011?
Ensure brevity in your answer.  9.27. What is the average Persistence rate to the last grade of primary education (%) in Central Europe per year?
Provide a short and direct response. 96.94. What is the average Persistence rate to the last grade of primary education (%) of Middle East & North Africa (all income levels) per year?
Your response must be concise. 85.26. What is the average Persistence rate to the last grade of primary education (%) in Kazakhstan per year?
Ensure brevity in your answer.  99.3. What is the average Persistence rate to the last grade of primary education (%) in Lebanon per year?
Ensure brevity in your answer.  88.43. In the year 2003, what is the difference between the Persistence rate to the last grade of primary education (%) of Central Europe and Persistence rate to the last grade of primary education (%) of Middle East & North Africa (all income levels)?
Keep it short and to the point. 12.91. In the year 2003, what is the difference between the Persistence rate to the last grade of primary education (%) of Central Europe and Persistence rate to the last grade of primary education (%) of Kazakhstan?
Your answer should be very brief. -2.52. In the year 2003, what is the difference between the Persistence rate to the last grade of primary education (%) in Central Europe and Persistence rate to the last grade of primary education (%) in Lebanon?
Give a very brief answer. 6.59. In the year 2003, what is the difference between the Persistence rate to the last grade of primary education (%) of Middle East & North Africa (all income levels) and Persistence rate to the last grade of primary education (%) of Kazakhstan?
Your answer should be very brief. -15.42. In the year 2003, what is the difference between the Persistence rate to the last grade of primary education (%) of Middle East & North Africa (all income levels) and Persistence rate to the last grade of primary education (%) of Lebanon?
Ensure brevity in your answer.  -6.31. In the year 2003, what is the difference between the Persistence rate to the last grade of primary education (%) of Kazakhstan and Persistence rate to the last grade of primary education (%) of Lebanon?
Offer a very short reply. 9.11. In the year 2004, what is the difference between the Persistence rate to the last grade of primary education (%) in Central Europe and Persistence rate to the last grade of primary education (%) in Middle East & North Africa (all income levels)?
Give a very brief answer. 14.17. In the year 2004, what is the difference between the Persistence rate to the last grade of primary education (%) in Central Europe and Persistence rate to the last grade of primary education (%) in Kazakhstan?
Ensure brevity in your answer.  -2.07. In the year 2004, what is the difference between the Persistence rate to the last grade of primary education (%) in Central Europe and Persistence rate to the last grade of primary education (%) in Lebanon?
Give a very brief answer. 10.69. In the year 2004, what is the difference between the Persistence rate to the last grade of primary education (%) of Middle East & North Africa (all income levels) and Persistence rate to the last grade of primary education (%) of Kazakhstan?
Offer a very short reply. -16.24. In the year 2004, what is the difference between the Persistence rate to the last grade of primary education (%) in Middle East & North Africa (all income levels) and Persistence rate to the last grade of primary education (%) in Lebanon?
Ensure brevity in your answer.  -3.48. In the year 2004, what is the difference between the Persistence rate to the last grade of primary education (%) of Kazakhstan and Persistence rate to the last grade of primary education (%) of Lebanon?
Offer a very short reply. 12.76. In the year 2005, what is the difference between the Persistence rate to the last grade of primary education (%) in Central Europe and Persistence rate to the last grade of primary education (%) in Middle East & North Africa (all income levels)?
Your response must be concise. 13.74. In the year 2005, what is the difference between the Persistence rate to the last grade of primary education (%) of Central Europe and Persistence rate to the last grade of primary education (%) of Kazakhstan?
Your answer should be very brief. -1.69. In the year 2005, what is the difference between the Persistence rate to the last grade of primary education (%) in Central Europe and Persistence rate to the last grade of primary education (%) in Lebanon?
Provide a succinct answer. 13.11. In the year 2005, what is the difference between the Persistence rate to the last grade of primary education (%) in Middle East & North Africa (all income levels) and Persistence rate to the last grade of primary education (%) in Kazakhstan?
Provide a short and direct response. -15.42. In the year 2005, what is the difference between the Persistence rate to the last grade of primary education (%) in Middle East & North Africa (all income levels) and Persistence rate to the last grade of primary education (%) in Lebanon?
Provide a succinct answer. -0.63. In the year 2005, what is the difference between the Persistence rate to the last grade of primary education (%) in Kazakhstan and Persistence rate to the last grade of primary education (%) in Lebanon?
Give a very brief answer. 14.79. In the year 2006, what is the difference between the Persistence rate to the last grade of primary education (%) of Central Europe and Persistence rate to the last grade of primary education (%) of Middle East & North Africa (all income levels)?
Your answer should be very brief. 11.95. In the year 2006, what is the difference between the Persistence rate to the last grade of primary education (%) of Central Europe and Persistence rate to the last grade of primary education (%) of Kazakhstan?
Offer a terse response. -3.23. In the year 2006, what is the difference between the Persistence rate to the last grade of primary education (%) in Central Europe and Persistence rate to the last grade of primary education (%) in Lebanon?
Offer a very short reply. 4.71. In the year 2006, what is the difference between the Persistence rate to the last grade of primary education (%) in Middle East & North Africa (all income levels) and Persistence rate to the last grade of primary education (%) in Kazakhstan?
Provide a succinct answer. -15.18. In the year 2006, what is the difference between the Persistence rate to the last grade of primary education (%) of Middle East & North Africa (all income levels) and Persistence rate to the last grade of primary education (%) of Lebanon?
Ensure brevity in your answer.  -7.23. In the year 2006, what is the difference between the Persistence rate to the last grade of primary education (%) of Kazakhstan and Persistence rate to the last grade of primary education (%) of Lebanon?
Offer a terse response. 7.94. In the year 2007, what is the difference between the Persistence rate to the last grade of primary education (%) in Central Europe and Persistence rate to the last grade of primary education (%) in Middle East & North Africa (all income levels)?
Provide a short and direct response. 11.29. In the year 2007, what is the difference between the Persistence rate to the last grade of primary education (%) in Central Europe and Persistence rate to the last grade of primary education (%) in Kazakhstan?
Make the answer very short. -2.6. In the year 2007, what is the difference between the Persistence rate to the last grade of primary education (%) of Central Europe and Persistence rate to the last grade of primary education (%) of Lebanon?
Give a very brief answer. 10.33. In the year 2007, what is the difference between the Persistence rate to the last grade of primary education (%) of Middle East & North Africa (all income levels) and Persistence rate to the last grade of primary education (%) of Kazakhstan?
Offer a very short reply. -13.89. In the year 2007, what is the difference between the Persistence rate to the last grade of primary education (%) of Middle East & North Africa (all income levels) and Persistence rate to the last grade of primary education (%) of Lebanon?
Offer a terse response. -0.96. In the year 2007, what is the difference between the Persistence rate to the last grade of primary education (%) in Kazakhstan and Persistence rate to the last grade of primary education (%) in Lebanon?
Provide a succinct answer. 12.93. In the year 2008, what is the difference between the Persistence rate to the last grade of primary education (%) of Central Europe and Persistence rate to the last grade of primary education (%) of Middle East & North Africa (all income levels)?
Provide a succinct answer. 10.81. In the year 2008, what is the difference between the Persistence rate to the last grade of primary education (%) in Central Europe and Persistence rate to the last grade of primary education (%) in Kazakhstan?
Ensure brevity in your answer.  -2.2. In the year 2008, what is the difference between the Persistence rate to the last grade of primary education (%) of Central Europe and Persistence rate to the last grade of primary education (%) of Lebanon?
Your answer should be very brief. 6.14. In the year 2008, what is the difference between the Persistence rate to the last grade of primary education (%) in Middle East & North Africa (all income levels) and Persistence rate to the last grade of primary education (%) in Kazakhstan?
Your response must be concise. -13. In the year 2008, what is the difference between the Persistence rate to the last grade of primary education (%) in Middle East & North Africa (all income levels) and Persistence rate to the last grade of primary education (%) in Lebanon?
Keep it short and to the point. -4.67. In the year 2008, what is the difference between the Persistence rate to the last grade of primary education (%) of Kazakhstan and Persistence rate to the last grade of primary education (%) of Lebanon?
Your answer should be compact. 8.34. In the year 2010, what is the difference between the Persistence rate to the last grade of primary education (%) of Central Europe and Persistence rate to the last grade of primary education (%) of Middle East & North Africa (all income levels)?
Offer a very short reply. 8.89. In the year 2010, what is the difference between the Persistence rate to the last grade of primary education (%) in Central Europe and Persistence rate to the last grade of primary education (%) in Kazakhstan?
Provide a short and direct response. -2.41. In the year 2010, what is the difference between the Persistence rate to the last grade of primary education (%) of Central Europe and Persistence rate to the last grade of primary education (%) of Lebanon?
Your answer should be very brief. 9.82. In the year 2010, what is the difference between the Persistence rate to the last grade of primary education (%) in Middle East & North Africa (all income levels) and Persistence rate to the last grade of primary education (%) in Kazakhstan?
Your answer should be compact. -11.3. In the year 2010, what is the difference between the Persistence rate to the last grade of primary education (%) in Middle East & North Africa (all income levels) and Persistence rate to the last grade of primary education (%) in Lebanon?
Offer a terse response. 0.93. In the year 2010, what is the difference between the Persistence rate to the last grade of primary education (%) in Kazakhstan and Persistence rate to the last grade of primary education (%) in Lebanon?
Offer a very short reply. 12.23. In the year 2011, what is the difference between the Persistence rate to the last grade of primary education (%) in Central Europe and Persistence rate to the last grade of primary education (%) in Middle East & North Africa (all income levels)?
Provide a short and direct response. 9.72. In the year 2011, what is the difference between the Persistence rate to the last grade of primary education (%) in Central Europe and Persistence rate to the last grade of primary education (%) in Kazakhstan?
Offer a very short reply. -2.16. In the year 2011, what is the difference between the Persistence rate to the last grade of primary education (%) of Central Europe and Persistence rate to the last grade of primary education (%) of Lebanon?
Provide a succinct answer. 6.72. In the year 2011, what is the difference between the Persistence rate to the last grade of primary education (%) of Middle East & North Africa (all income levels) and Persistence rate to the last grade of primary education (%) of Kazakhstan?
Provide a succinct answer. -11.88. In the year 2011, what is the difference between the Persistence rate to the last grade of primary education (%) of Middle East & North Africa (all income levels) and Persistence rate to the last grade of primary education (%) of Lebanon?
Provide a succinct answer. -3. In the year 2011, what is the difference between the Persistence rate to the last grade of primary education (%) of Kazakhstan and Persistence rate to the last grade of primary education (%) of Lebanon?
Your response must be concise. 8.88. What is the ratio of the Persistence rate to the last grade of primary education (%) of Central Europe in 2003 to that in 2004?
Your response must be concise. 1. What is the ratio of the Persistence rate to the last grade of primary education (%) in Middle East & North Africa (all income levels) in 2003 to that in 2004?
Keep it short and to the point. 1.02. What is the ratio of the Persistence rate to the last grade of primary education (%) in Kazakhstan in 2003 to that in 2004?
Offer a very short reply. 1.01. What is the ratio of the Persistence rate to the last grade of primary education (%) of Lebanon in 2003 to that in 2004?
Provide a short and direct response. 1.05. What is the ratio of the Persistence rate to the last grade of primary education (%) of Middle East & North Africa (all income levels) in 2003 to that in 2005?
Give a very brief answer. 1.02. What is the ratio of the Persistence rate to the last grade of primary education (%) in Kazakhstan in 2003 to that in 2005?
Offer a very short reply. 1.01. What is the ratio of the Persistence rate to the last grade of primary education (%) of Lebanon in 2003 to that in 2005?
Provide a short and direct response. 1.08. What is the ratio of the Persistence rate to the last grade of primary education (%) of Central Europe in 2003 to that in 2006?
Ensure brevity in your answer.  1.01. What is the ratio of the Persistence rate to the last grade of primary education (%) in Lebanon in 2003 to that in 2006?
Offer a very short reply. 0.99. What is the ratio of the Persistence rate to the last grade of primary education (%) of Central Europe in 2003 to that in 2007?
Your answer should be compact. 1.01. What is the ratio of the Persistence rate to the last grade of primary education (%) in Middle East & North Africa (all income levels) in 2003 to that in 2007?
Keep it short and to the point. 0.99. What is the ratio of the Persistence rate to the last grade of primary education (%) of Kazakhstan in 2003 to that in 2007?
Keep it short and to the point. 1.01. What is the ratio of the Persistence rate to the last grade of primary education (%) in Lebanon in 2003 to that in 2007?
Keep it short and to the point. 1.06. What is the ratio of the Persistence rate to the last grade of primary education (%) of Central Europe in 2003 to that in 2008?
Make the answer very short. 1.01. What is the ratio of the Persistence rate to the last grade of primary education (%) of Middle East & North Africa (all income levels) in 2003 to that in 2008?
Your answer should be very brief. 0.99. What is the ratio of the Persistence rate to the last grade of primary education (%) in Kazakhstan in 2003 to that in 2008?
Give a very brief answer. 1.01. What is the ratio of the Persistence rate to the last grade of primary education (%) in Lebanon in 2003 to that in 2008?
Ensure brevity in your answer.  1.01. What is the ratio of the Persistence rate to the last grade of primary education (%) in Middle East & North Africa (all income levels) in 2003 to that in 2010?
Provide a succinct answer. 0.96. What is the ratio of the Persistence rate to the last grade of primary education (%) of Kazakhstan in 2003 to that in 2010?
Your answer should be compact. 1. What is the ratio of the Persistence rate to the last grade of primary education (%) of Lebanon in 2003 to that in 2010?
Keep it short and to the point. 1.04. What is the ratio of the Persistence rate to the last grade of primary education (%) in Central Europe in 2003 to that in 2011?
Make the answer very short. 1. What is the ratio of the Persistence rate to the last grade of primary education (%) of Middle East & North Africa (all income levels) in 2003 to that in 2011?
Your answer should be very brief. 0.97. What is the ratio of the Persistence rate to the last grade of primary education (%) of Kazakhstan in 2003 to that in 2011?
Offer a very short reply. 1.01. What is the ratio of the Persistence rate to the last grade of primary education (%) in Middle East & North Africa (all income levels) in 2004 to that in 2005?
Give a very brief answer. 1. What is the ratio of the Persistence rate to the last grade of primary education (%) of Kazakhstan in 2004 to that in 2005?
Make the answer very short. 1.01. What is the ratio of the Persistence rate to the last grade of primary education (%) of Lebanon in 2004 to that in 2005?
Offer a terse response. 1.03. What is the ratio of the Persistence rate to the last grade of primary education (%) of Central Europe in 2004 to that in 2006?
Keep it short and to the point. 1.01. What is the ratio of the Persistence rate to the last grade of primary education (%) of Middle East & North Africa (all income levels) in 2004 to that in 2006?
Provide a succinct answer. 0.98. What is the ratio of the Persistence rate to the last grade of primary education (%) in Lebanon in 2004 to that in 2006?
Offer a very short reply. 0.94. What is the ratio of the Persistence rate to the last grade of primary education (%) of Middle East & North Africa (all income levels) in 2004 to that in 2007?
Give a very brief answer. 0.98. What is the ratio of the Persistence rate to the last grade of primary education (%) in Kazakhstan in 2004 to that in 2007?
Provide a short and direct response. 1. What is the ratio of the Persistence rate to the last grade of primary education (%) in Central Europe in 2004 to that in 2008?
Offer a very short reply. 1.01. What is the ratio of the Persistence rate to the last grade of primary education (%) of Kazakhstan in 2004 to that in 2008?
Give a very brief answer. 1.01. What is the ratio of the Persistence rate to the last grade of primary education (%) in Lebanon in 2004 to that in 2008?
Ensure brevity in your answer.  0.96. What is the ratio of the Persistence rate to the last grade of primary education (%) in Central Europe in 2004 to that in 2010?
Your answer should be very brief. 1. What is the ratio of the Persistence rate to the last grade of primary education (%) of Middle East & North Africa (all income levels) in 2004 to that in 2010?
Make the answer very short. 0.94. What is the ratio of the Persistence rate to the last grade of primary education (%) in Lebanon in 2004 to that in 2010?
Give a very brief answer. 0.99. What is the ratio of the Persistence rate to the last grade of primary education (%) of Central Europe in 2004 to that in 2011?
Provide a succinct answer. 1. What is the ratio of the Persistence rate to the last grade of primary education (%) of Middle East & North Africa (all income levels) in 2004 to that in 2011?
Offer a terse response. 0.95. What is the ratio of the Persistence rate to the last grade of primary education (%) in Lebanon in 2004 to that in 2011?
Offer a terse response. 0.96. What is the ratio of the Persistence rate to the last grade of primary education (%) in Central Europe in 2005 to that in 2006?
Offer a very short reply. 1.01. What is the ratio of the Persistence rate to the last grade of primary education (%) in Middle East & North Africa (all income levels) in 2005 to that in 2006?
Your response must be concise. 0.99. What is the ratio of the Persistence rate to the last grade of primary education (%) in Lebanon in 2005 to that in 2006?
Your answer should be compact. 0.92. What is the ratio of the Persistence rate to the last grade of primary education (%) in Central Europe in 2005 to that in 2007?
Provide a succinct answer. 1.01. What is the ratio of the Persistence rate to the last grade of primary education (%) in Middle East & North Africa (all income levels) in 2005 to that in 2007?
Your response must be concise. 0.98. What is the ratio of the Persistence rate to the last grade of primary education (%) in Lebanon in 2005 to that in 2007?
Ensure brevity in your answer.  0.97. What is the ratio of the Persistence rate to the last grade of primary education (%) of Central Europe in 2005 to that in 2008?
Provide a short and direct response. 1.01. What is the ratio of the Persistence rate to the last grade of primary education (%) in Middle East & North Africa (all income levels) in 2005 to that in 2008?
Keep it short and to the point. 0.97. What is the ratio of the Persistence rate to the last grade of primary education (%) in Kazakhstan in 2005 to that in 2008?
Offer a very short reply. 1. What is the ratio of the Persistence rate to the last grade of primary education (%) in Lebanon in 2005 to that in 2008?
Make the answer very short. 0.93. What is the ratio of the Persistence rate to the last grade of primary education (%) of Middle East & North Africa (all income levels) in 2005 to that in 2010?
Provide a succinct answer. 0.94. What is the ratio of the Persistence rate to the last grade of primary education (%) in Lebanon in 2005 to that in 2010?
Provide a succinct answer. 0.96. What is the ratio of the Persistence rate to the last grade of primary education (%) in Central Europe in 2005 to that in 2011?
Keep it short and to the point. 1. What is the ratio of the Persistence rate to the last grade of primary education (%) of Middle East & North Africa (all income levels) in 2005 to that in 2011?
Give a very brief answer. 0.95. What is the ratio of the Persistence rate to the last grade of primary education (%) of Kazakhstan in 2005 to that in 2011?
Give a very brief answer. 0.99. What is the ratio of the Persistence rate to the last grade of primary education (%) in Lebanon in 2005 to that in 2011?
Offer a terse response. 0.93. What is the ratio of the Persistence rate to the last grade of primary education (%) of Kazakhstan in 2006 to that in 2007?
Give a very brief answer. 1.01. What is the ratio of the Persistence rate to the last grade of primary education (%) in Lebanon in 2006 to that in 2007?
Give a very brief answer. 1.06. What is the ratio of the Persistence rate to the last grade of primary education (%) in Middle East & North Africa (all income levels) in 2006 to that in 2008?
Provide a short and direct response. 0.99. What is the ratio of the Persistence rate to the last grade of primary education (%) in Kazakhstan in 2006 to that in 2008?
Your response must be concise. 1.01. What is the ratio of the Persistence rate to the last grade of primary education (%) in Lebanon in 2006 to that in 2008?
Provide a succinct answer. 1.01. What is the ratio of the Persistence rate to the last grade of primary education (%) of Middle East & North Africa (all income levels) in 2006 to that in 2010?
Keep it short and to the point. 0.95. What is the ratio of the Persistence rate to the last grade of primary education (%) in Kazakhstan in 2006 to that in 2010?
Your answer should be compact. 1. What is the ratio of the Persistence rate to the last grade of primary education (%) of Lebanon in 2006 to that in 2010?
Your answer should be very brief. 1.05. What is the ratio of the Persistence rate to the last grade of primary education (%) in Kazakhstan in 2006 to that in 2011?
Provide a succinct answer. 1. What is the ratio of the Persistence rate to the last grade of primary education (%) of Lebanon in 2006 to that in 2011?
Give a very brief answer. 1.01. What is the ratio of the Persistence rate to the last grade of primary education (%) of Central Europe in 2007 to that in 2008?
Ensure brevity in your answer.  1. What is the ratio of the Persistence rate to the last grade of primary education (%) of Middle East & North Africa (all income levels) in 2007 to that in 2008?
Offer a terse response. 0.99. What is the ratio of the Persistence rate to the last grade of primary education (%) in Kazakhstan in 2007 to that in 2008?
Offer a very short reply. 1. What is the ratio of the Persistence rate to the last grade of primary education (%) of Lebanon in 2007 to that in 2008?
Provide a short and direct response. 0.95. What is the ratio of the Persistence rate to the last grade of primary education (%) of Central Europe in 2007 to that in 2010?
Make the answer very short. 0.99. What is the ratio of the Persistence rate to the last grade of primary education (%) in Middle East & North Africa (all income levels) in 2007 to that in 2010?
Your answer should be very brief. 0.96. What is the ratio of the Persistence rate to the last grade of primary education (%) in Kazakhstan in 2007 to that in 2010?
Your response must be concise. 0.99. What is the ratio of the Persistence rate to the last grade of primary education (%) of Lebanon in 2007 to that in 2010?
Make the answer very short. 0.98. What is the ratio of the Persistence rate to the last grade of primary education (%) in Middle East & North Africa (all income levels) in 2007 to that in 2011?
Your response must be concise. 0.97. What is the ratio of the Persistence rate to the last grade of primary education (%) of Kazakhstan in 2007 to that in 2011?
Give a very brief answer. 1. What is the ratio of the Persistence rate to the last grade of primary education (%) of Lebanon in 2007 to that in 2011?
Provide a short and direct response. 0.95. What is the ratio of the Persistence rate to the last grade of primary education (%) of Central Europe in 2008 to that in 2010?
Offer a very short reply. 0.99. What is the ratio of the Persistence rate to the last grade of primary education (%) of Middle East & North Africa (all income levels) in 2008 to that in 2010?
Provide a short and direct response. 0.97. What is the ratio of the Persistence rate to the last grade of primary education (%) in Lebanon in 2008 to that in 2010?
Provide a succinct answer. 1.03. What is the ratio of the Persistence rate to the last grade of primary education (%) in Middle East & North Africa (all income levels) in 2008 to that in 2011?
Offer a very short reply. 0.98. What is the ratio of the Persistence rate to the last grade of primary education (%) of Kazakhstan in 2008 to that in 2011?
Provide a short and direct response. 0.99. What is the ratio of the Persistence rate to the last grade of primary education (%) of Lebanon in 2008 to that in 2011?
Keep it short and to the point. 1. What is the ratio of the Persistence rate to the last grade of primary education (%) of Middle East & North Africa (all income levels) in 2010 to that in 2011?
Your answer should be very brief. 1.01. What is the ratio of the Persistence rate to the last grade of primary education (%) of Lebanon in 2010 to that in 2011?
Offer a very short reply. 0.97. What is the difference between the highest and the second highest Persistence rate to the last grade of primary education (%) of Central Europe?
Offer a very short reply. 0.13. What is the difference between the highest and the second highest Persistence rate to the last grade of primary education (%) of Middle East & North Africa (all income levels)?
Your response must be concise. 0.97. What is the difference between the highest and the second highest Persistence rate to the last grade of primary education (%) of Kazakhstan?
Make the answer very short. 0.23. What is the difference between the highest and the second highest Persistence rate to the last grade of primary education (%) of Lebanon?
Keep it short and to the point. 0.77. What is the difference between the highest and the lowest Persistence rate to the last grade of primary education (%) in Central Europe?
Give a very brief answer. 1.11. What is the difference between the highest and the lowest Persistence rate to the last grade of primary education (%) in Middle East & North Africa (all income levels)?
Make the answer very short. 5.36. What is the difference between the highest and the lowest Persistence rate to the last grade of primary education (%) in Kazakhstan?
Your answer should be compact. 1.33. What is the difference between the highest and the lowest Persistence rate to the last grade of primary education (%) in Lebanon?
Give a very brief answer. 7.78. 